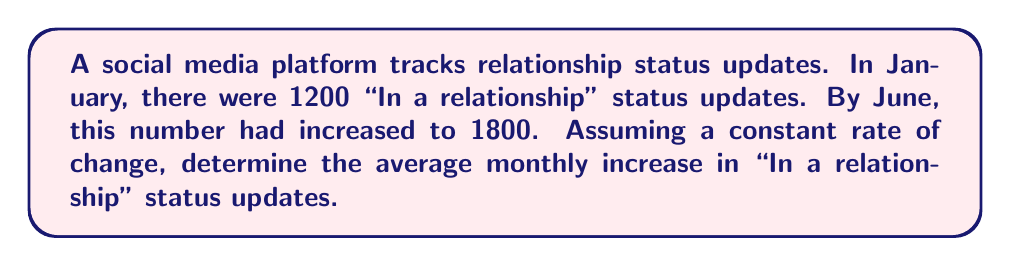Help me with this question. To solve this problem, we'll follow these steps:

1. Identify the given information:
   - Initial value (January): 1200 status updates
   - Final value (June): 1800 status updates
   - Time period: 6 months (January to June, inclusive)

2. Calculate the total change in status updates:
   $$\text{Total change} = \text{Final value} - \text{Initial value}$$
   $$\text{Total change} = 1800 - 1200 = 600$$

3. Calculate the rate of change per month:
   $$\text{Rate of change} = \frac{\text{Total change}}{\text{Number of months}}$$
   $$\text{Rate of change} = \frac{600}{6} = 100$$

Therefore, the average monthly increase in "In a relationship" status updates is 100.
Answer: 100 status updates per month 